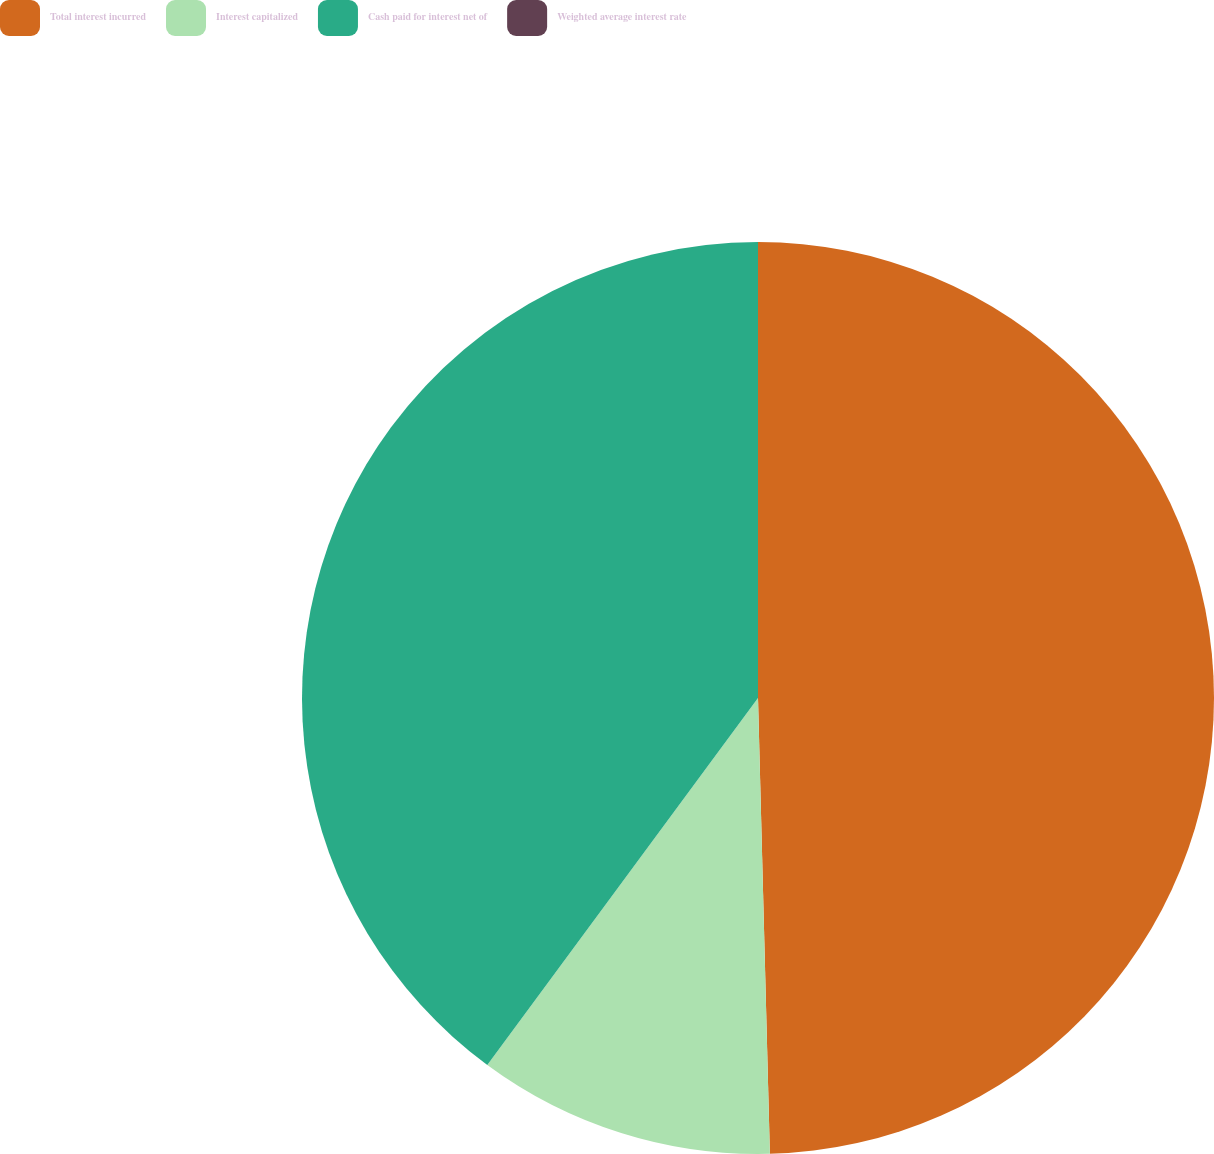Convert chart. <chart><loc_0><loc_0><loc_500><loc_500><pie_chart><fcel>Total interest incurred<fcel>Interest capitalized<fcel>Cash paid for interest net of<fcel>Weighted average interest rate<nl><fcel>49.58%<fcel>10.53%<fcel>39.88%<fcel>0.0%<nl></chart> 